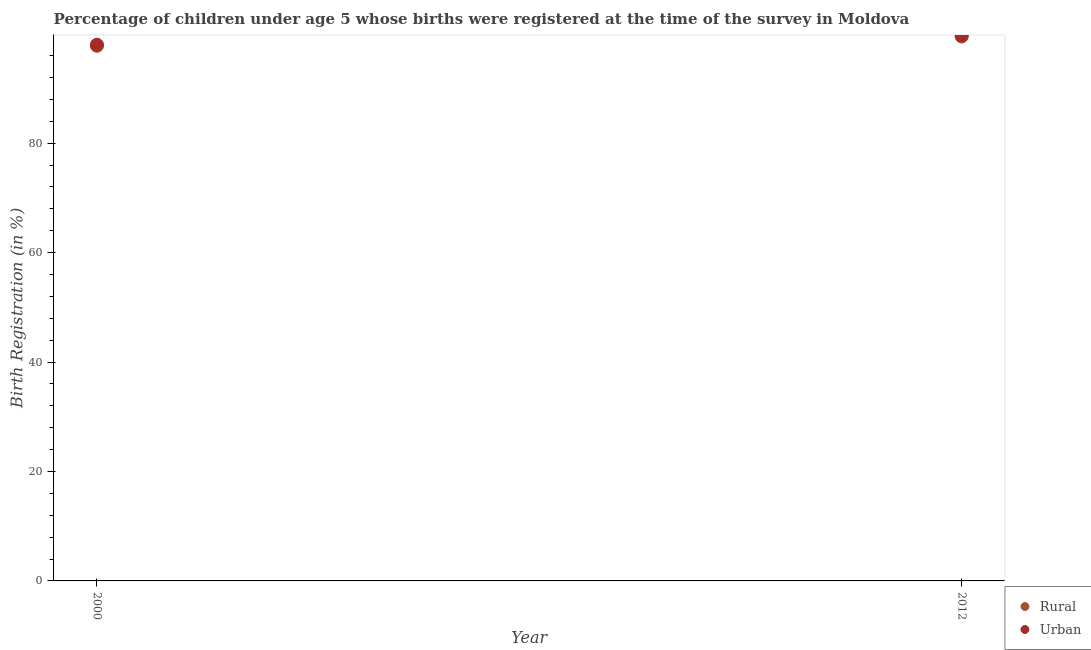How many different coloured dotlines are there?
Provide a short and direct response. 2. Is the number of dotlines equal to the number of legend labels?
Offer a terse response. Yes. What is the rural birth registration in 2000?
Provide a succinct answer. 97.8. Across all years, what is the maximum urban birth registration?
Keep it short and to the point. 99.7. In which year was the rural birth registration maximum?
Make the answer very short. 2012. In which year was the rural birth registration minimum?
Ensure brevity in your answer.  2000. What is the total urban birth registration in the graph?
Provide a short and direct response. 197.7. What is the difference between the urban birth registration in 2000 and that in 2012?
Give a very brief answer. -1.7. What is the average urban birth registration per year?
Your answer should be compact. 98.85. In the year 2000, what is the difference between the urban birth registration and rural birth registration?
Your response must be concise. 0.2. In how many years, is the rural birth registration greater than 36 %?
Make the answer very short. 2. What is the ratio of the rural birth registration in 2000 to that in 2012?
Give a very brief answer. 0.98. In how many years, is the rural birth registration greater than the average rural birth registration taken over all years?
Keep it short and to the point. 1. Is the rural birth registration strictly greater than the urban birth registration over the years?
Offer a very short reply. No. Is the rural birth registration strictly less than the urban birth registration over the years?
Keep it short and to the point. Yes. How many dotlines are there?
Ensure brevity in your answer.  2. How many years are there in the graph?
Your answer should be very brief. 2. Are the values on the major ticks of Y-axis written in scientific E-notation?
Your answer should be very brief. No. How are the legend labels stacked?
Your answer should be very brief. Vertical. What is the title of the graph?
Your response must be concise. Percentage of children under age 5 whose births were registered at the time of the survey in Moldova. Does "Female entrants" appear as one of the legend labels in the graph?
Provide a short and direct response. No. What is the label or title of the Y-axis?
Give a very brief answer. Birth Registration (in %). What is the Birth Registration (in %) in Rural in 2000?
Keep it short and to the point. 97.8. What is the Birth Registration (in %) of Urban in 2000?
Your answer should be compact. 98. What is the Birth Registration (in %) in Rural in 2012?
Your answer should be compact. 99.5. What is the Birth Registration (in %) of Urban in 2012?
Give a very brief answer. 99.7. Across all years, what is the maximum Birth Registration (in %) of Rural?
Give a very brief answer. 99.5. Across all years, what is the maximum Birth Registration (in %) of Urban?
Provide a short and direct response. 99.7. Across all years, what is the minimum Birth Registration (in %) of Rural?
Keep it short and to the point. 97.8. Across all years, what is the minimum Birth Registration (in %) in Urban?
Keep it short and to the point. 98. What is the total Birth Registration (in %) in Rural in the graph?
Offer a terse response. 197.3. What is the total Birth Registration (in %) of Urban in the graph?
Offer a terse response. 197.7. What is the difference between the Birth Registration (in %) in Urban in 2000 and that in 2012?
Provide a succinct answer. -1.7. What is the average Birth Registration (in %) of Rural per year?
Provide a short and direct response. 98.65. What is the average Birth Registration (in %) of Urban per year?
Your response must be concise. 98.85. What is the ratio of the Birth Registration (in %) of Rural in 2000 to that in 2012?
Keep it short and to the point. 0.98. What is the ratio of the Birth Registration (in %) in Urban in 2000 to that in 2012?
Keep it short and to the point. 0.98. What is the difference between the highest and the second highest Birth Registration (in %) in Rural?
Offer a very short reply. 1.7. What is the difference between the highest and the lowest Birth Registration (in %) of Urban?
Ensure brevity in your answer.  1.7. 